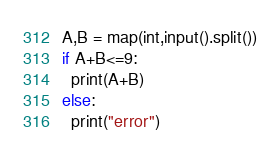Convert code to text. <code><loc_0><loc_0><loc_500><loc_500><_Python_>A,B = map(int,input().split())
if A+B<=9:
  print(A+B)
else:
  print("error")</code> 